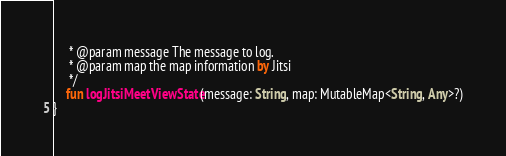<code> <loc_0><loc_0><loc_500><loc_500><_Kotlin_>     * @param message The message to log.
     * @param map the map information by Jitsi
     */
    fun logJitsiMeetViewState(message: String, map: MutableMap<String, Any>?)
}</code> 